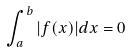<formula> <loc_0><loc_0><loc_500><loc_500>\int _ { a } ^ { b } | f ( x ) | d x = 0</formula> 